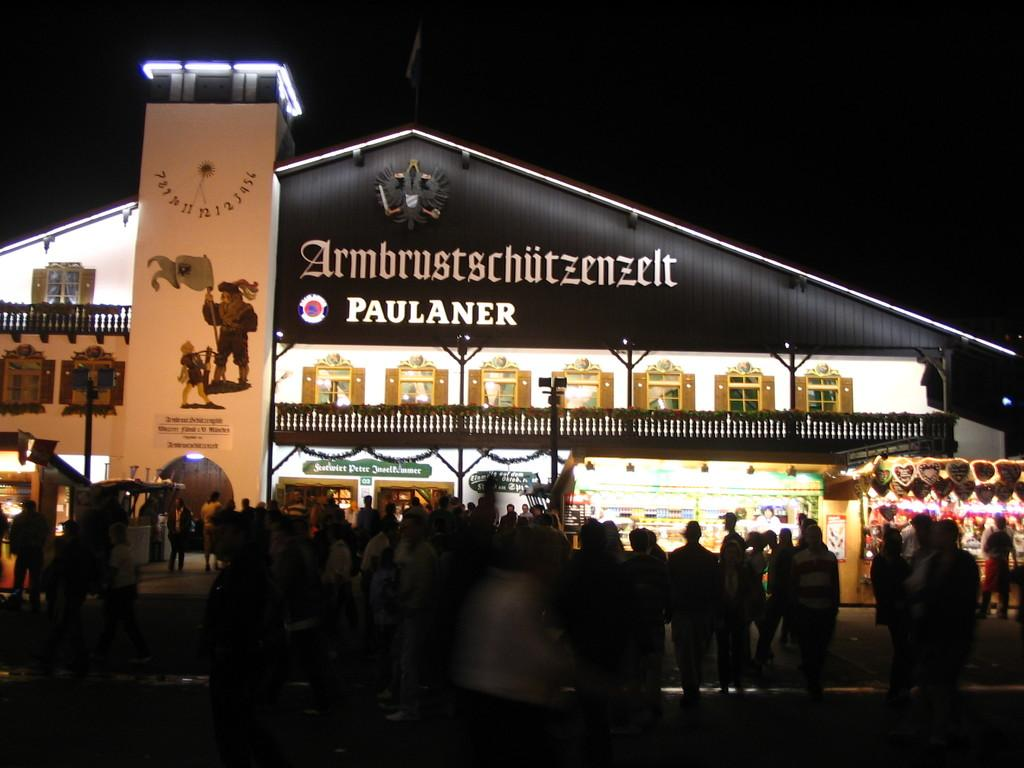What can be seen in the image? There are people standing in the image. What is visible in the background of the image? There are buildings and a board with written text in the background of the image. Can you see any goats in the image? No, there are no goats present in the image. What type of cracker is being used to create the quilt in the image? There is no quilt or cracker present in the image. 